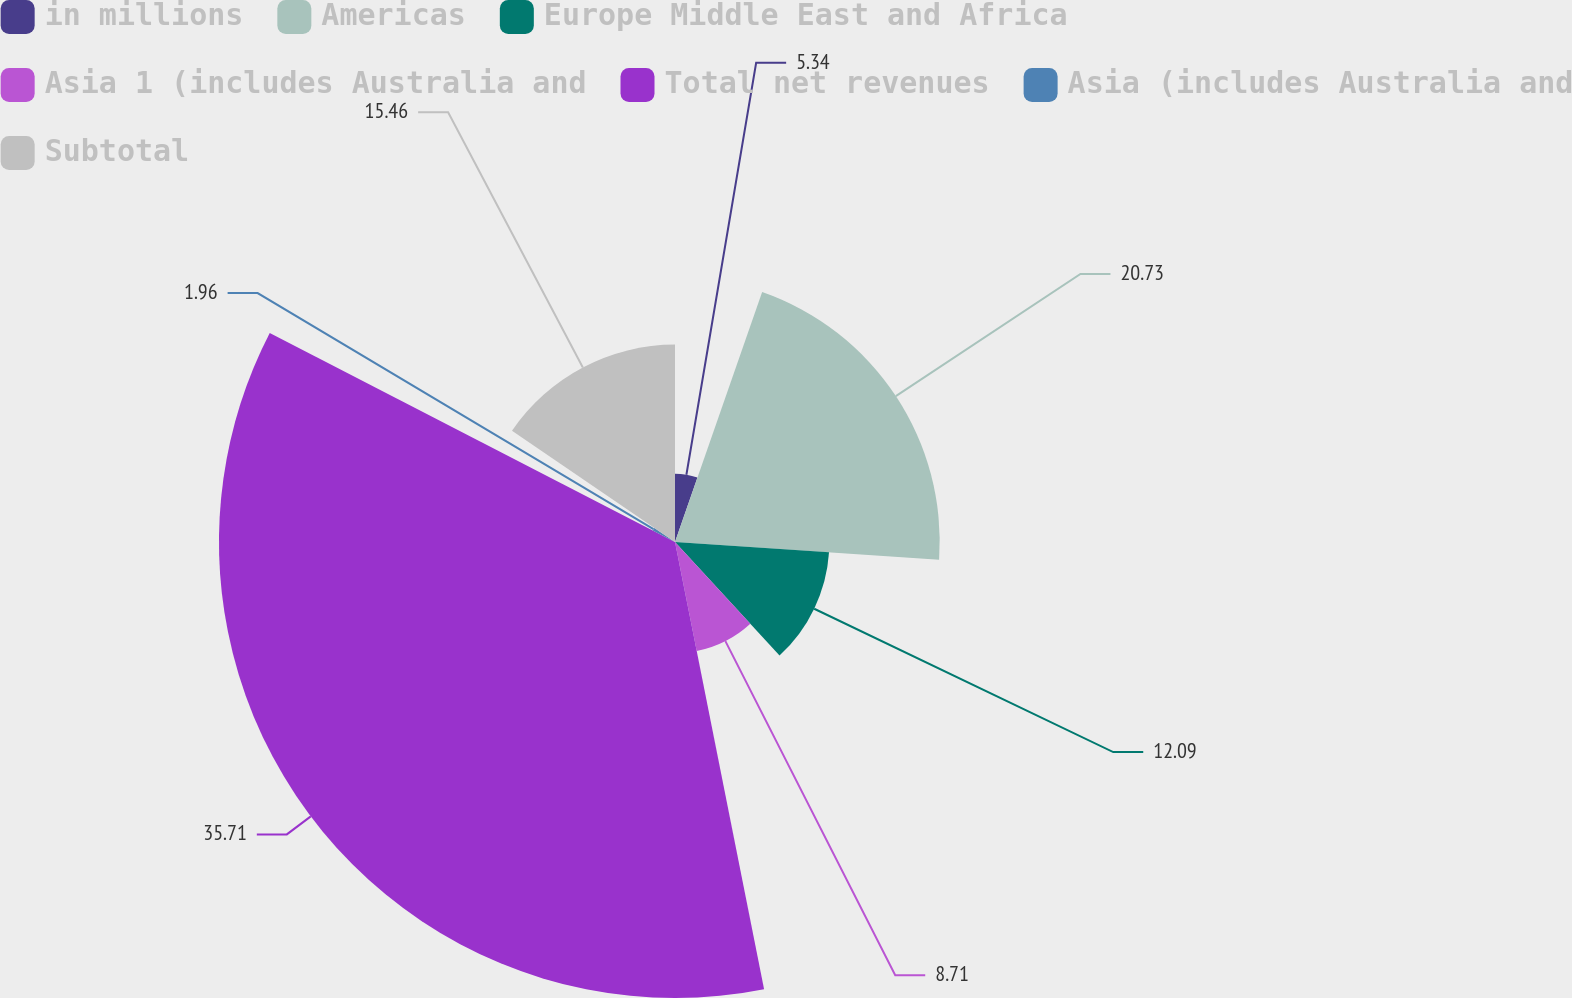Convert chart to OTSL. <chart><loc_0><loc_0><loc_500><loc_500><pie_chart><fcel>in millions<fcel>Americas<fcel>Europe Middle East and Africa<fcel>Asia 1 (includes Australia and<fcel>Total net revenues<fcel>Asia (includes Australia and<fcel>Subtotal<nl><fcel>5.34%<fcel>20.73%<fcel>12.09%<fcel>8.71%<fcel>35.71%<fcel>1.96%<fcel>15.46%<nl></chart> 